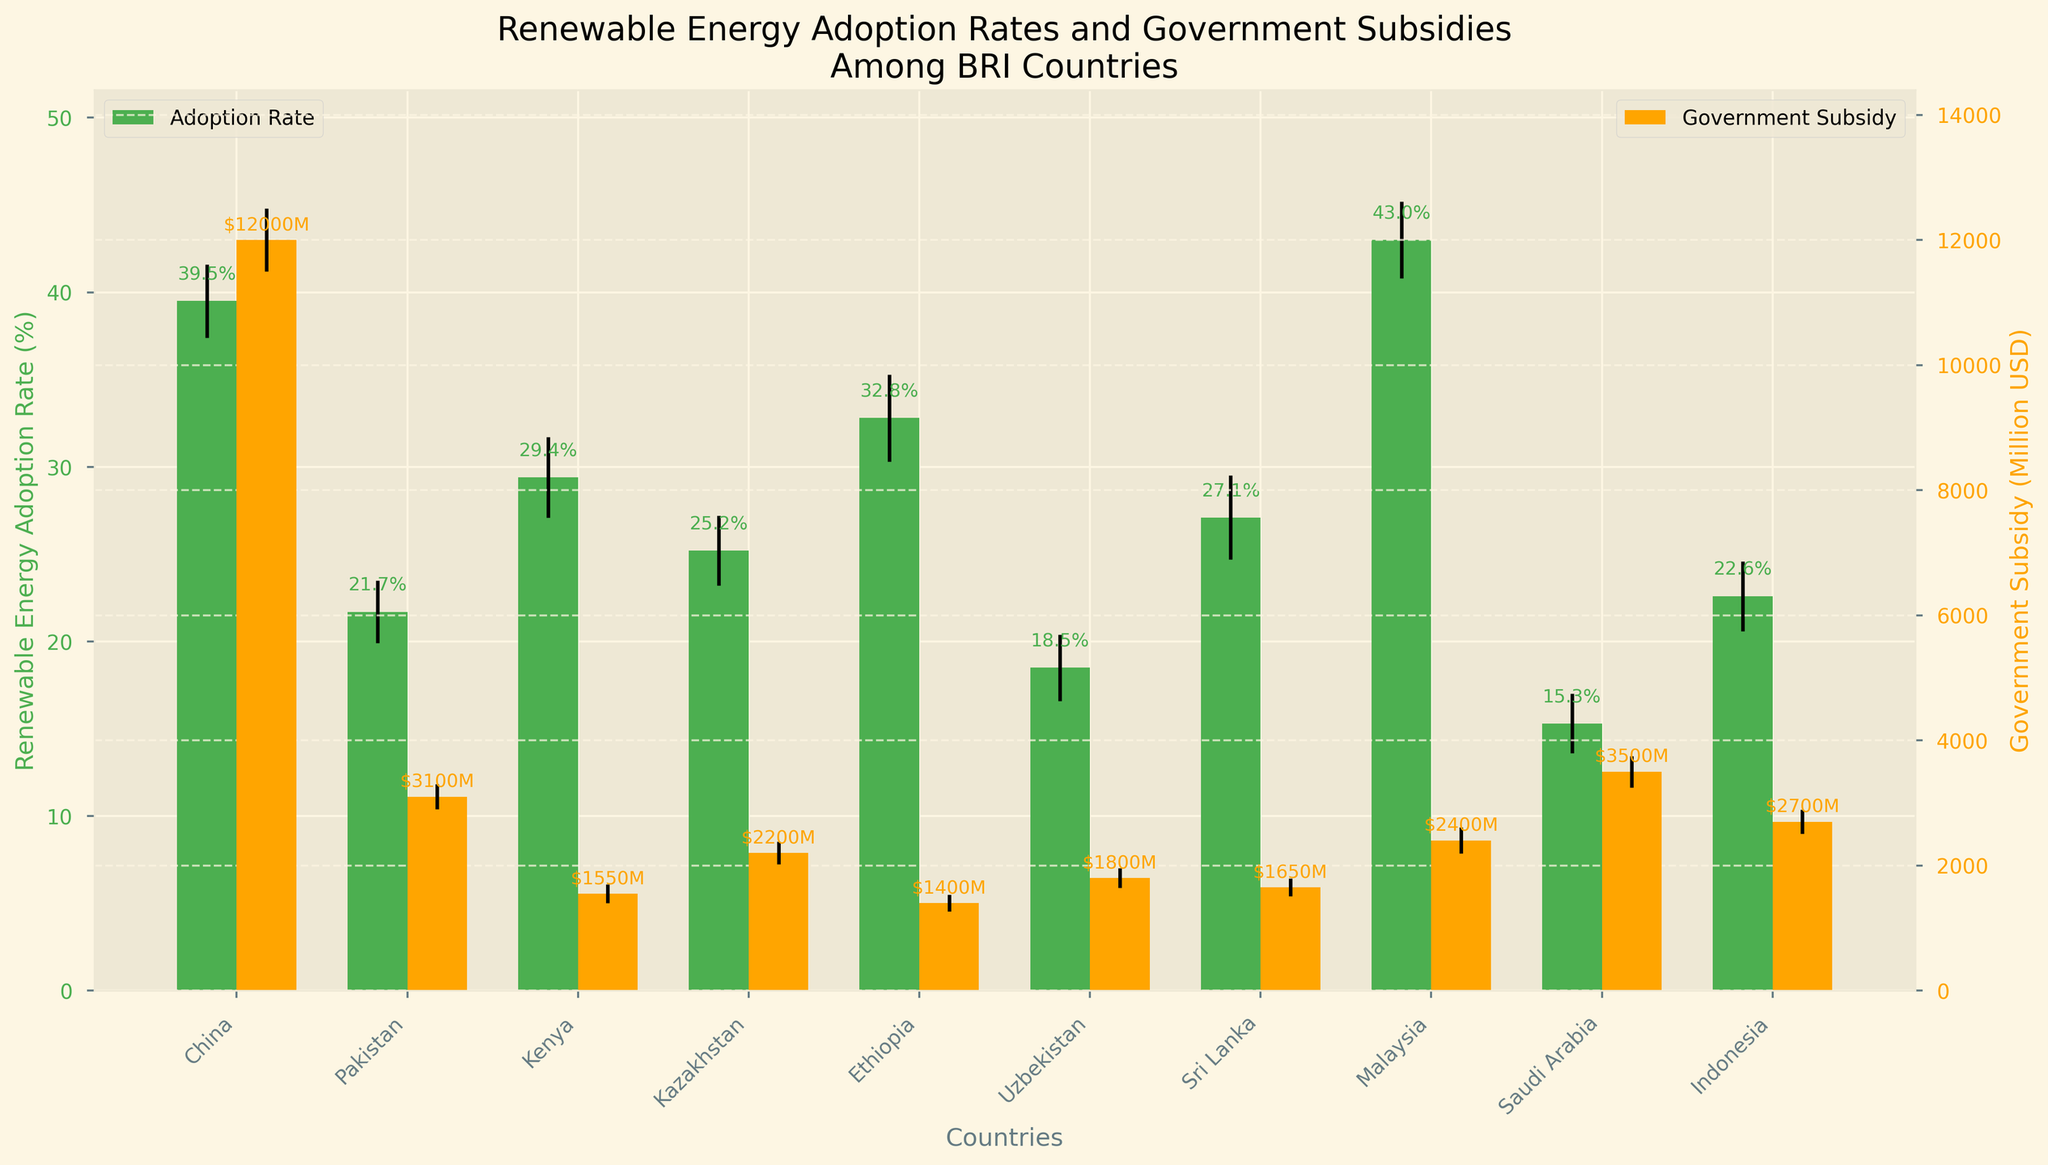What is the title of the figure? The title is located at the top of the figure and helps to understand what the data is about. Here, it gives a context for the data being displayed, which is about renewable energy adoption rates and government subsidies among BRI countries.
Answer: Renewable Energy Adoption Rates and Government Subsidies Among BRI Countries What are the two y-axes representing in the figure? The figure has two y-axes on the left and right. The left y-axis represents the renewable energy adoption rate in percentages, and the right y-axis represents the government subsidy in million USD.
Answer: Renewable energy adoption rate in % and government subsidy in million USD Which country has the highest renewable energy adoption rate? By identifying the heights of the green bars aligned with each country on the x-axis, we can determine that the country with the highest renewable energy adoption rate is China's bar.
Answer: China Which country receives the highest government subsidy? By examining the heights of the orange bars aligned with each country on the x-axis, we can determine that the country receiving the highest government subsidy is China's bar.
Answer: China What is the renewable energy adoption rate for Pakistan? Locate the green bar for Pakistan on the x-axis and read its height based on the y-axis label on the left. The renewable energy adoption rate for Pakistan is about 21.7%.
Answer: 21.7% What is the difference in government subsidy between Indonesia and Saudi Arabia? Find the heights of the orange bars for Indonesia and Saudi Arabia on the x-axis, reading the values from the right y-axis. The difference is calculated as 3500 million USD (Saudi Arabia) - 2700 million USD (Indonesia).
Answer: 800 million USD Which country has the lowest renewable energy adoption rate and what is the value? Check all the green bars and identify the shortest one, which indicates the lowest rate. Saudi Arabia has the lowest rate, and it is 15.3%.
Answer: Saudi Arabia, 15.3% What is the government subsidy for Malaysia, and how does it compare to Pakistan's subsidy? Find the orange bars for Malaysia and Pakistan on the x-axis and read their values according to the right y-axis. Malaysia receives 2400 million USD, whereas Pakistan receives 3100 million USD. Thus, Pakistan receives more subsidy than Malaysia.
Answer: Malaysia: 2400 million USD, Pakistan: 3100 million USD, Pakistan receives more Which country has the largest error margin in renewable energy adoption rate? Observe the error bars extending from the top of each green bar. The widest error bar indicates the largest error margin. Ethiopia's error margin is the largest at 2.5%.
Answer: Ethiopia Is the government subsidy for Ethiopia greater than that for Kenya? Compare the heights of the orange bars for Ethiopia and Kenya and read their values according to the right y-axis. Ethiopia's subsidy is 1400 million USD, whereas Kenya's subsidy is 1550 million USD. Kenya's subsidy is slightly higher.
Answer: No 